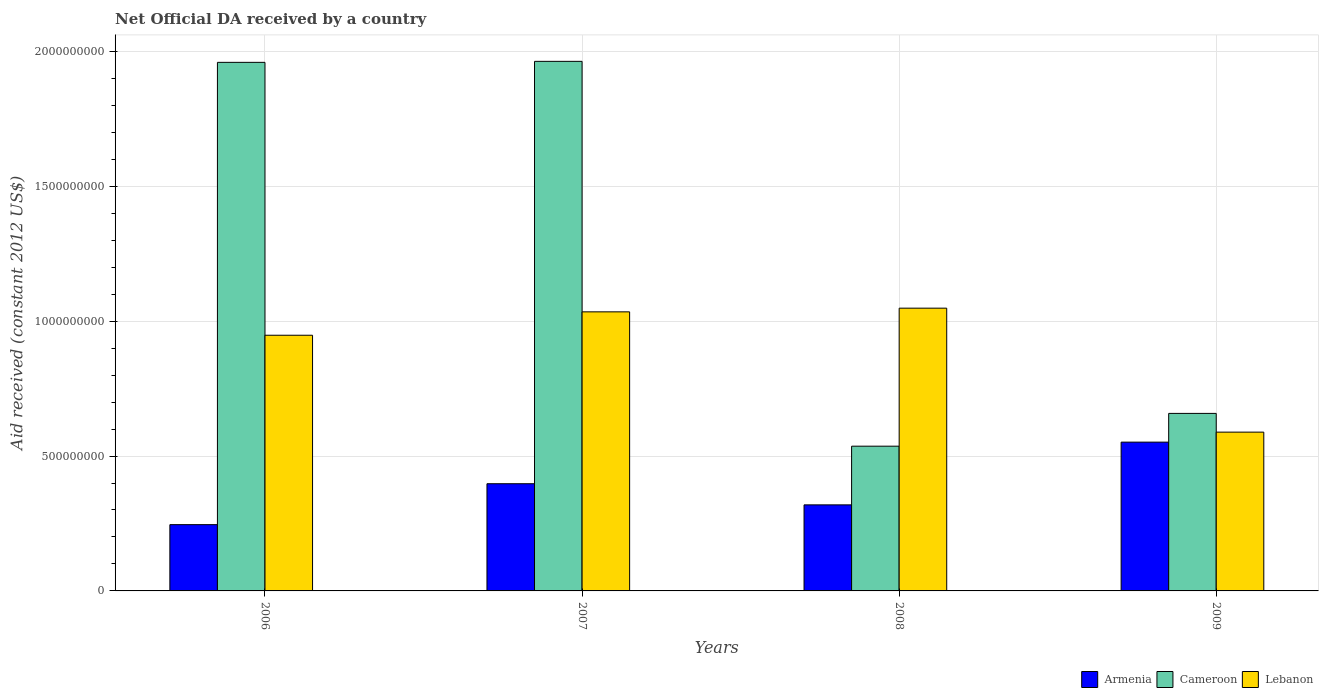How many different coloured bars are there?
Ensure brevity in your answer.  3. Are the number of bars per tick equal to the number of legend labels?
Provide a succinct answer. Yes. Are the number of bars on each tick of the X-axis equal?
Give a very brief answer. Yes. How many bars are there on the 4th tick from the left?
Make the answer very short. 3. In how many cases, is the number of bars for a given year not equal to the number of legend labels?
Offer a terse response. 0. What is the net official development assistance aid received in Lebanon in 2006?
Give a very brief answer. 9.48e+08. Across all years, what is the maximum net official development assistance aid received in Cameroon?
Your response must be concise. 1.96e+09. Across all years, what is the minimum net official development assistance aid received in Armenia?
Your answer should be compact. 2.46e+08. What is the total net official development assistance aid received in Armenia in the graph?
Offer a terse response. 1.51e+09. What is the difference between the net official development assistance aid received in Lebanon in 2006 and that in 2008?
Your answer should be compact. -1.00e+08. What is the difference between the net official development assistance aid received in Cameroon in 2008 and the net official development assistance aid received in Armenia in 2009?
Your answer should be very brief. -1.50e+07. What is the average net official development assistance aid received in Armenia per year?
Provide a short and direct response. 3.78e+08. In the year 2009, what is the difference between the net official development assistance aid received in Lebanon and net official development assistance aid received in Armenia?
Provide a succinct answer. 3.70e+07. In how many years, is the net official development assistance aid received in Cameroon greater than 1500000000 US$?
Provide a succinct answer. 2. What is the ratio of the net official development assistance aid received in Lebanon in 2006 to that in 2007?
Offer a terse response. 0.92. Is the net official development assistance aid received in Lebanon in 2006 less than that in 2009?
Make the answer very short. No. Is the difference between the net official development assistance aid received in Lebanon in 2008 and 2009 greater than the difference between the net official development assistance aid received in Armenia in 2008 and 2009?
Ensure brevity in your answer.  Yes. What is the difference between the highest and the second highest net official development assistance aid received in Lebanon?
Provide a short and direct response. 1.37e+07. What is the difference between the highest and the lowest net official development assistance aid received in Armenia?
Provide a succinct answer. 3.06e+08. In how many years, is the net official development assistance aid received in Cameroon greater than the average net official development assistance aid received in Cameroon taken over all years?
Give a very brief answer. 2. What does the 2nd bar from the left in 2009 represents?
Your answer should be very brief. Cameroon. What does the 1st bar from the right in 2007 represents?
Ensure brevity in your answer.  Lebanon. Is it the case that in every year, the sum of the net official development assistance aid received in Armenia and net official development assistance aid received in Cameroon is greater than the net official development assistance aid received in Lebanon?
Your answer should be very brief. No. Are all the bars in the graph horizontal?
Offer a terse response. No. How many years are there in the graph?
Offer a very short reply. 4. What is the difference between two consecutive major ticks on the Y-axis?
Give a very brief answer. 5.00e+08. Does the graph contain any zero values?
Ensure brevity in your answer.  No. How many legend labels are there?
Offer a terse response. 3. What is the title of the graph?
Offer a terse response. Net Official DA received by a country. Does "El Salvador" appear as one of the legend labels in the graph?
Provide a short and direct response. No. What is the label or title of the Y-axis?
Ensure brevity in your answer.  Aid received (constant 2012 US$). What is the Aid received (constant 2012 US$) in Armenia in 2006?
Provide a short and direct response. 2.46e+08. What is the Aid received (constant 2012 US$) of Cameroon in 2006?
Your answer should be compact. 1.96e+09. What is the Aid received (constant 2012 US$) in Lebanon in 2006?
Make the answer very short. 9.48e+08. What is the Aid received (constant 2012 US$) in Armenia in 2007?
Make the answer very short. 3.97e+08. What is the Aid received (constant 2012 US$) in Cameroon in 2007?
Your answer should be compact. 1.96e+09. What is the Aid received (constant 2012 US$) of Lebanon in 2007?
Your answer should be very brief. 1.03e+09. What is the Aid received (constant 2012 US$) in Armenia in 2008?
Provide a short and direct response. 3.19e+08. What is the Aid received (constant 2012 US$) of Cameroon in 2008?
Offer a very short reply. 5.36e+08. What is the Aid received (constant 2012 US$) of Lebanon in 2008?
Provide a succinct answer. 1.05e+09. What is the Aid received (constant 2012 US$) in Armenia in 2009?
Provide a short and direct response. 5.52e+08. What is the Aid received (constant 2012 US$) in Cameroon in 2009?
Offer a very short reply. 6.58e+08. What is the Aid received (constant 2012 US$) in Lebanon in 2009?
Your answer should be compact. 5.89e+08. Across all years, what is the maximum Aid received (constant 2012 US$) in Armenia?
Offer a very short reply. 5.52e+08. Across all years, what is the maximum Aid received (constant 2012 US$) of Cameroon?
Make the answer very short. 1.96e+09. Across all years, what is the maximum Aid received (constant 2012 US$) of Lebanon?
Your response must be concise. 1.05e+09. Across all years, what is the minimum Aid received (constant 2012 US$) in Armenia?
Provide a succinct answer. 2.46e+08. Across all years, what is the minimum Aid received (constant 2012 US$) in Cameroon?
Your answer should be very brief. 5.36e+08. Across all years, what is the minimum Aid received (constant 2012 US$) in Lebanon?
Your answer should be compact. 5.89e+08. What is the total Aid received (constant 2012 US$) in Armenia in the graph?
Ensure brevity in your answer.  1.51e+09. What is the total Aid received (constant 2012 US$) of Cameroon in the graph?
Provide a succinct answer. 5.12e+09. What is the total Aid received (constant 2012 US$) in Lebanon in the graph?
Keep it short and to the point. 3.62e+09. What is the difference between the Aid received (constant 2012 US$) of Armenia in 2006 and that in 2007?
Keep it short and to the point. -1.52e+08. What is the difference between the Aid received (constant 2012 US$) of Cameroon in 2006 and that in 2007?
Your answer should be very brief. -3.72e+06. What is the difference between the Aid received (constant 2012 US$) of Lebanon in 2006 and that in 2007?
Make the answer very short. -8.67e+07. What is the difference between the Aid received (constant 2012 US$) of Armenia in 2006 and that in 2008?
Give a very brief answer. -7.33e+07. What is the difference between the Aid received (constant 2012 US$) in Cameroon in 2006 and that in 2008?
Give a very brief answer. 1.42e+09. What is the difference between the Aid received (constant 2012 US$) in Lebanon in 2006 and that in 2008?
Give a very brief answer. -1.00e+08. What is the difference between the Aid received (constant 2012 US$) in Armenia in 2006 and that in 2009?
Offer a very short reply. -3.06e+08. What is the difference between the Aid received (constant 2012 US$) of Cameroon in 2006 and that in 2009?
Provide a short and direct response. 1.30e+09. What is the difference between the Aid received (constant 2012 US$) in Lebanon in 2006 and that in 2009?
Make the answer very short. 3.59e+08. What is the difference between the Aid received (constant 2012 US$) of Armenia in 2007 and that in 2008?
Provide a short and direct response. 7.83e+07. What is the difference between the Aid received (constant 2012 US$) of Cameroon in 2007 and that in 2008?
Make the answer very short. 1.43e+09. What is the difference between the Aid received (constant 2012 US$) in Lebanon in 2007 and that in 2008?
Your response must be concise. -1.37e+07. What is the difference between the Aid received (constant 2012 US$) of Armenia in 2007 and that in 2009?
Keep it short and to the point. -1.54e+08. What is the difference between the Aid received (constant 2012 US$) of Cameroon in 2007 and that in 2009?
Provide a short and direct response. 1.30e+09. What is the difference between the Aid received (constant 2012 US$) of Lebanon in 2007 and that in 2009?
Make the answer very short. 4.46e+08. What is the difference between the Aid received (constant 2012 US$) of Armenia in 2008 and that in 2009?
Ensure brevity in your answer.  -2.33e+08. What is the difference between the Aid received (constant 2012 US$) of Cameroon in 2008 and that in 2009?
Give a very brief answer. -1.21e+08. What is the difference between the Aid received (constant 2012 US$) in Lebanon in 2008 and that in 2009?
Ensure brevity in your answer.  4.59e+08. What is the difference between the Aid received (constant 2012 US$) in Armenia in 2006 and the Aid received (constant 2012 US$) in Cameroon in 2007?
Provide a succinct answer. -1.72e+09. What is the difference between the Aid received (constant 2012 US$) in Armenia in 2006 and the Aid received (constant 2012 US$) in Lebanon in 2007?
Provide a short and direct response. -7.89e+08. What is the difference between the Aid received (constant 2012 US$) of Cameroon in 2006 and the Aid received (constant 2012 US$) of Lebanon in 2007?
Keep it short and to the point. 9.25e+08. What is the difference between the Aid received (constant 2012 US$) of Armenia in 2006 and the Aid received (constant 2012 US$) of Cameroon in 2008?
Give a very brief answer. -2.91e+08. What is the difference between the Aid received (constant 2012 US$) of Armenia in 2006 and the Aid received (constant 2012 US$) of Lebanon in 2008?
Provide a succinct answer. -8.02e+08. What is the difference between the Aid received (constant 2012 US$) of Cameroon in 2006 and the Aid received (constant 2012 US$) of Lebanon in 2008?
Your answer should be very brief. 9.11e+08. What is the difference between the Aid received (constant 2012 US$) in Armenia in 2006 and the Aid received (constant 2012 US$) in Cameroon in 2009?
Your answer should be very brief. -4.12e+08. What is the difference between the Aid received (constant 2012 US$) in Armenia in 2006 and the Aid received (constant 2012 US$) in Lebanon in 2009?
Offer a very short reply. -3.43e+08. What is the difference between the Aid received (constant 2012 US$) in Cameroon in 2006 and the Aid received (constant 2012 US$) in Lebanon in 2009?
Provide a short and direct response. 1.37e+09. What is the difference between the Aid received (constant 2012 US$) of Armenia in 2007 and the Aid received (constant 2012 US$) of Cameroon in 2008?
Provide a short and direct response. -1.39e+08. What is the difference between the Aid received (constant 2012 US$) in Armenia in 2007 and the Aid received (constant 2012 US$) in Lebanon in 2008?
Your answer should be compact. -6.51e+08. What is the difference between the Aid received (constant 2012 US$) in Cameroon in 2007 and the Aid received (constant 2012 US$) in Lebanon in 2008?
Give a very brief answer. 9.15e+08. What is the difference between the Aid received (constant 2012 US$) of Armenia in 2007 and the Aid received (constant 2012 US$) of Cameroon in 2009?
Provide a short and direct response. -2.61e+08. What is the difference between the Aid received (constant 2012 US$) of Armenia in 2007 and the Aid received (constant 2012 US$) of Lebanon in 2009?
Give a very brief answer. -1.91e+08. What is the difference between the Aid received (constant 2012 US$) in Cameroon in 2007 and the Aid received (constant 2012 US$) in Lebanon in 2009?
Your answer should be compact. 1.37e+09. What is the difference between the Aid received (constant 2012 US$) of Armenia in 2008 and the Aid received (constant 2012 US$) of Cameroon in 2009?
Offer a very short reply. -3.39e+08. What is the difference between the Aid received (constant 2012 US$) of Armenia in 2008 and the Aid received (constant 2012 US$) of Lebanon in 2009?
Provide a succinct answer. -2.70e+08. What is the difference between the Aid received (constant 2012 US$) of Cameroon in 2008 and the Aid received (constant 2012 US$) of Lebanon in 2009?
Offer a terse response. -5.21e+07. What is the average Aid received (constant 2012 US$) in Armenia per year?
Offer a terse response. 3.78e+08. What is the average Aid received (constant 2012 US$) of Cameroon per year?
Ensure brevity in your answer.  1.28e+09. What is the average Aid received (constant 2012 US$) in Lebanon per year?
Your answer should be compact. 9.05e+08. In the year 2006, what is the difference between the Aid received (constant 2012 US$) of Armenia and Aid received (constant 2012 US$) of Cameroon?
Your answer should be compact. -1.71e+09. In the year 2006, what is the difference between the Aid received (constant 2012 US$) in Armenia and Aid received (constant 2012 US$) in Lebanon?
Your answer should be very brief. -7.02e+08. In the year 2006, what is the difference between the Aid received (constant 2012 US$) of Cameroon and Aid received (constant 2012 US$) of Lebanon?
Offer a very short reply. 1.01e+09. In the year 2007, what is the difference between the Aid received (constant 2012 US$) in Armenia and Aid received (constant 2012 US$) in Cameroon?
Your answer should be very brief. -1.57e+09. In the year 2007, what is the difference between the Aid received (constant 2012 US$) of Armenia and Aid received (constant 2012 US$) of Lebanon?
Make the answer very short. -6.37e+08. In the year 2007, what is the difference between the Aid received (constant 2012 US$) in Cameroon and Aid received (constant 2012 US$) in Lebanon?
Provide a short and direct response. 9.28e+08. In the year 2008, what is the difference between the Aid received (constant 2012 US$) in Armenia and Aid received (constant 2012 US$) in Cameroon?
Your answer should be compact. -2.18e+08. In the year 2008, what is the difference between the Aid received (constant 2012 US$) in Armenia and Aid received (constant 2012 US$) in Lebanon?
Offer a terse response. -7.29e+08. In the year 2008, what is the difference between the Aid received (constant 2012 US$) in Cameroon and Aid received (constant 2012 US$) in Lebanon?
Offer a very short reply. -5.12e+08. In the year 2009, what is the difference between the Aid received (constant 2012 US$) of Armenia and Aid received (constant 2012 US$) of Cameroon?
Ensure brevity in your answer.  -1.06e+08. In the year 2009, what is the difference between the Aid received (constant 2012 US$) of Armenia and Aid received (constant 2012 US$) of Lebanon?
Ensure brevity in your answer.  -3.70e+07. In the year 2009, what is the difference between the Aid received (constant 2012 US$) of Cameroon and Aid received (constant 2012 US$) of Lebanon?
Provide a short and direct response. 6.94e+07. What is the ratio of the Aid received (constant 2012 US$) of Armenia in 2006 to that in 2007?
Ensure brevity in your answer.  0.62. What is the ratio of the Aid received (constant 2012 US$) of Cameroon in 2006 to that in 2007?
Your response must be concise. 1. What is the ratio of the Aid received (constant 2012 US$) in Lebanon in 2006 to that in 2007?
Offer a terse response. 0.92. What is the ratio of the Aid received (constant 2012 US$) of Armenia in 2006 to that in 2008?
Your response must be concise. 0.77. What is the ratio of the Aid received (constant 2012 US$) of Cameroon in 2006 to that in 2008?
Your response must be concise. 3.65. What is the ratio of the Aid received (constant 2012 US$) of Lebanon in 2006 to that in 2008?
Keep it short and to the point. 0.9. What is the ratio of the Aid received (constant 2012 US$) of Armenia in 2006 to that in 2009?
Your response must be concise. 0.45. What is the ratio of the Aid received (constant 2012 US$) of Cameroon in 2006 to that in 2009?
Keep it short and to the point. 2.98. What is the ratio of the Aid received (constant 2012 US$) of Lebanon in 2006 to that in 2009?
Your response must be concise. 1.61. What is the ratio of the Aid received (constant 2012 US$) in Armenia in 2007 to that in 2008?
Give a very brief answer. 1.25. What is the ratio of the Aid received (constant 2012 US$) in Cameroon in 2007 to that in 2008?
Your answer should be compact. 3.66. What is the ratio of the Aid received (constant 2012 US$) in Lebanon in 2007 to that in 2008?
Your answer should be compact. 0.99. What is the ratio of the Aid received (constant 2012 US$) of Armenia in 2007 to that in 2009?
Offer a very short reply. 0.72. What is the ratio of the Aid received (constant 2012 US$) of Cameroon in 2007 to that in 2009?
Offer a terse response. 2.98. What is the ratio of the Aid received (constant 2012 US$) in Lebanon in 2007 to that in 2009?
Provide a succinct answer. 1.76. What is the ratio of the Aid received (constant 2012 US$) of Armenia in 2008 to that in 2009?
Give a very brief answer. 0.58. What is the ratio of the Aid received (constant 2012 US$) of Cameroon in 2008 to that in 2009?
Provide a succinct answer. 0.82. What is the ratio of the Aid received (constant 2012 US$) in Lebanon in 2008 to that in 2009?
Give a very brief answer. 1.78. What is the difference between the highest and the second highest Aid received (constant 2012 US$) of Armenia?
Your answer should be compact. 1.54e+08. What is the difference between the highest and the second highest Aid received (constant 2012 US$) of Cameroon?
Keep it short and to the point. 3.72e+06. What is the difference between the highest and the second highest Aid received (constant 2012 US$) of Lebanon?
Your response must be concise. 1.37e+07. What is the difference between the highest and the lowest Aid received (constant 2012 US$) of Armenia?
Offer a very short reply. 3.06e+08. What is the difference between the highest and the lowest Aid received (constant 2012 US$) of Cameroon?
Give a very brief answer. 1.43e+09. What is the difference between the highest and the lowest Aid received (constant 2012 US$) of Lebanon?
Keep it short and to the point. 4.59e+08. 